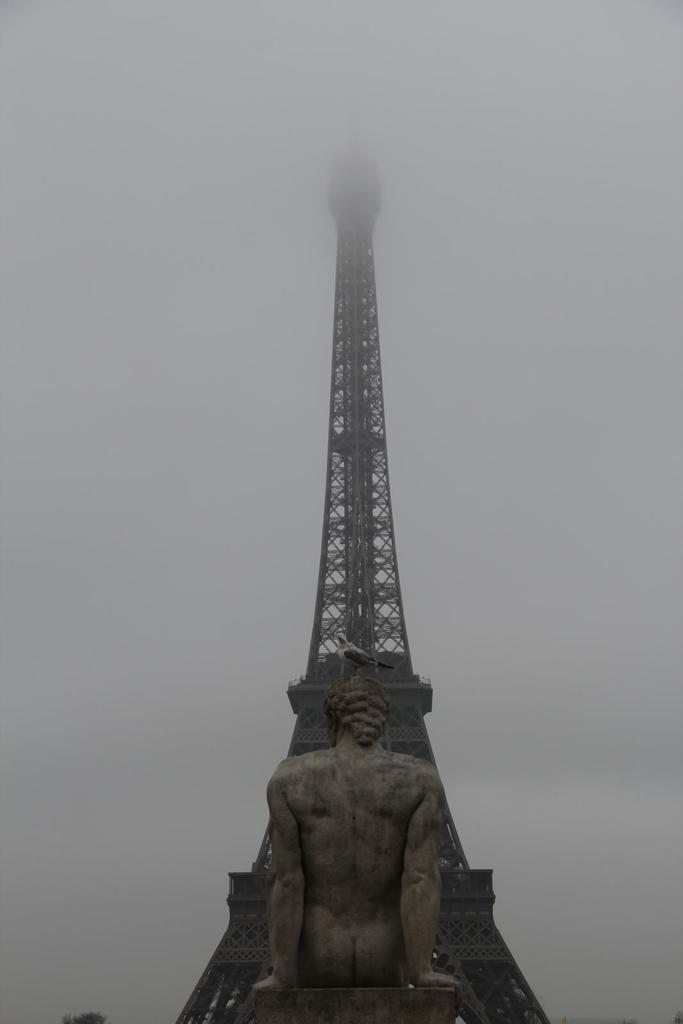What is the main structure in the image? There is a tower in the image. What is located in front of the tower? There is a statue in front of the tower. Is there any wildlife present in the image? Yes, there is a bird on the statue. What can be seen in the background of the image? The sky is visible in the background of the image. What type of plants can be seen growing on the tower in the image? There are no plants visible on the tower in the image. How many mice are hiding behind the statue in the image? There are no mice present in the image. 